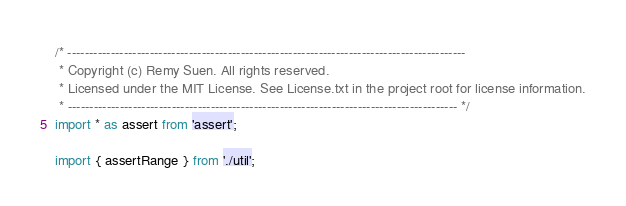Convert code to text. <code><loc_0><loc_0><loc_500><loc_500><_TypeScript_>/* --------------------------------------------------------------------------------------------
 * Copyright (c) Remy Suen. All rights reserved.
 * Licensed under the MIT License. See License.txt in the project root for license information.
 * ------------------------------------------------------------------------------------------ */
import * as assert from 'assert';

import { assertRange } from './util';</code> 